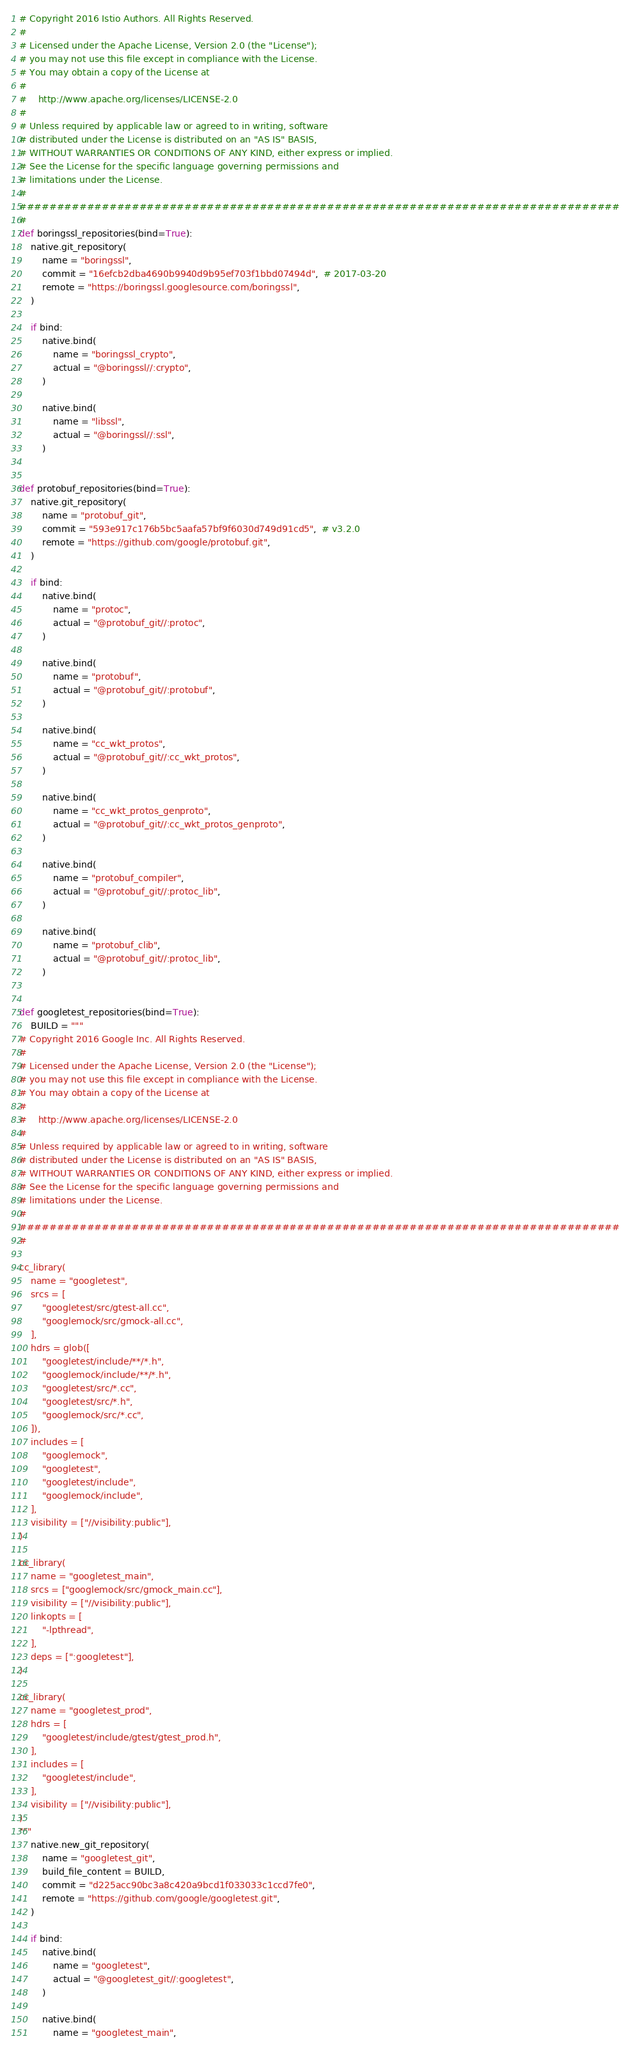<code> <loc_0><loc_0><loc_500><loc_500><_Python_># Copyright 2016 Istio Authors. All Rights Reserved.
#
# Licensed under the Apache License, Version 2.0 (the "License");
# you may not use this file except in compliance with the License.
# You may obtain a copy of the License at
#
#    http://www.apache.org/licenses/LICENSE-2.0
#
# Unless required by applicable law or agreed to in writing, software
# distributed under the License is distributed on an "AS IS" BASIS,
# WITHOUT WARRANTIES OR CONDITIONS OF ANY KIND, either express or implied.
# See the License for the specific language governing permissions and
# limitations under the License.
#
################################################################################
#
def boringssl_repositories(bind=True):
    native.git_repository(
        name = "boringssl",
        commit = "16efcb2dba4690b9940d9b95ef703f1bbd07494d",  # 2017-03-20
        remote = "https://boringssl.googlesource.com/boringssl",
    )

    if bind:
        native.bind(
            name = "boringssl_crypto",
            actual = "@boringssl//:crypto",
        )

        native.bind(
            name = "libssl",
            actual = "@boringssl//:ssl",
        )


def protobuf_repositories(bind=True):
    native.git_repository(
        name = "protobuf_git",
        commit = "593e917c176b5bc5aafa57bf9f6030d749d91cd5",  # v3.2.0
        remote = "https://github.com/google/protobuf.git",
    )

    if bind:
        native.bind(
            name = "protoc",
            actual = "@protobuf_git//:protoc",
        )

        native.bind(
            name = "protobuf",
            actual = "@protobuf_git//:protobuf",
        )

        native.bind(
            name = "cc_wkt_protos",
            actual = "@protobuf_git//:cc_wkt_protos",
        )

        native.bind(
            name = "cc_wkt_protos_genproto",
            actual = "@protobuf_git//:cc_wkt_protos_genproto",
        )

        native.bind(
            name = "protobuf_compiler",
            actual = "@protobuf_git//:protoc_lib",
        )

        native.bind(
            name = "protobuf_clib",
            actual = "@protobuf_git//:protoc_lib",
        )


def googletest_repositories(bind=True):
    BUILD = """
# Copyright 2016 Google Inc. All Rights Reserved.
#
# Licensed under the Apache License, Version 2.0 (the "License");
# you may not use this file except in compliance with the License.
# You may obtain a copy of the License at
#
#    http://www.apache.org/licenses/LICENSE-2.0
#
# Unless required by applicable law or agreed to in writing, software
# distributed under the License is distributed on an "AS IS" BASIS,
# WITHOUT WARRANTIES OR CONDITIONS OF ANY KIND, either express or implied.
# See the License for the specific language governing permissions and
# limitations under the License.
#
################################################################################
#

cc_library(
    name = "googletest",
    srcs = [
        "googletest/src/gtest-all.cc",
        "googlemock/src/gmock-all.cc",
    ],
    hdrs = glob([
        "googletest/include/**/*.h",
        "googlemock/include/**/*.h",
        "googletest/src/*.cc",
        "googletest/src/*.h",
        "googlemock/src/*.cc",
    ]),
    includes = [
        "googlemock",
        "googletest",
        "googletest/include",
        "googlemock/include",
    ],
    visibility = ["//visibility:public"],
)

cc_library(
    name = "googletest_main",
    srcs = ["googlemock/src/gmock_main.cc"],
    visibility = ["//visibility:public"],
    linkopts = [
        "-lpthread",
    ],
    deps = [":googletest"],
)

cc_library(
    name = "googletest_prod",
    hdrs = [
        "googletest/include/gtest/gtest_prod.h",
    ],
    includes = [
        "googletest/include",
    ],
    visibility = ["//visibility:public"],
)
"""
    native.new_git_repository(
        name = "googletest_git",
        build_file_content = BUILD,
        commit = "d225acc90bc3a8c420a9bcd1f033033c1ccd7fe0",
        remote = "https://github.com/google/googletest.git",
    )

    if bind:
        native.bind(
            name = "googletest",
            actual = "@googletest_git//:googletest",
        )

        native.bind(
            name = "googletest_main",</code> 